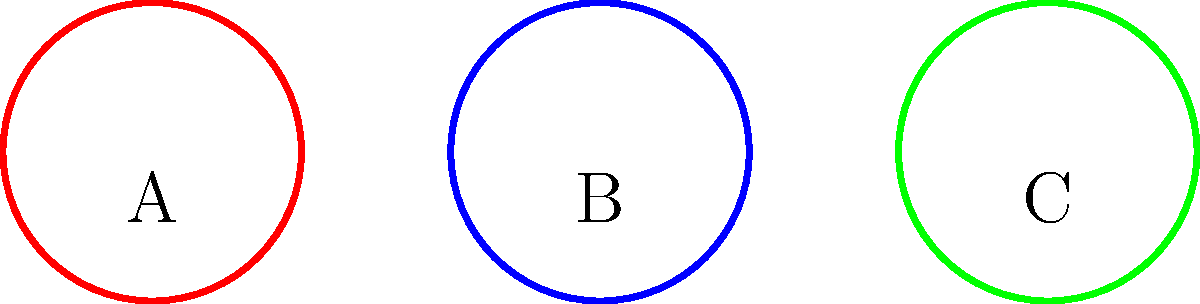In the context of marital conflicts represented as knots, which of the above knots (A, B, or C) best represents a conflict that can be resolved through open communication and active listening? To answer this question, we need to analyze the topological properties of each knot and relate them to marital conflicts:

1. Knot A (red): This is a simple closed curve with no crossings, known as an "unknot" or "trivial knot" in topology. In the context of marital conflicts, this represents a straightforward issue that can be easily resolved.

2. Knot B (blue): This appears to be a trefoil knot, which is the simplest non-trivial knot. It has three crossings and cannot be untangled without cutting. In marital conflicts, this could represent a more complex issue that requires effort to resolve but is still manageable.

3. Knot C (green): This seems to be a more complex knot with multiple crossings. In the context of marital conflicts, this might represent a deeply entangled issue that is difficult to resolve without professional help.

Given the persona of "A long-time friend who provides a listening ear and offers support and perspectives on building trust in marriage," the focus should be on conflicts that can be resolved through open communication and active listening.

The unknot (Knot A) best represents this type of conflict. It's a simple structure that can be "untangled" or resolved through straightforward communication techniques. Open communication and active listening are most effective for addressing clear, uncomplicated issues in a marriage, which aligns with the topological simplicity of the unknot.
Answer: A (the unknot) 